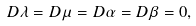<formula> <loc_0><loc_0><loc_500><loc_500>D \lambda = D \mu = D \alpha = D \beta = 0 ,</formula> 